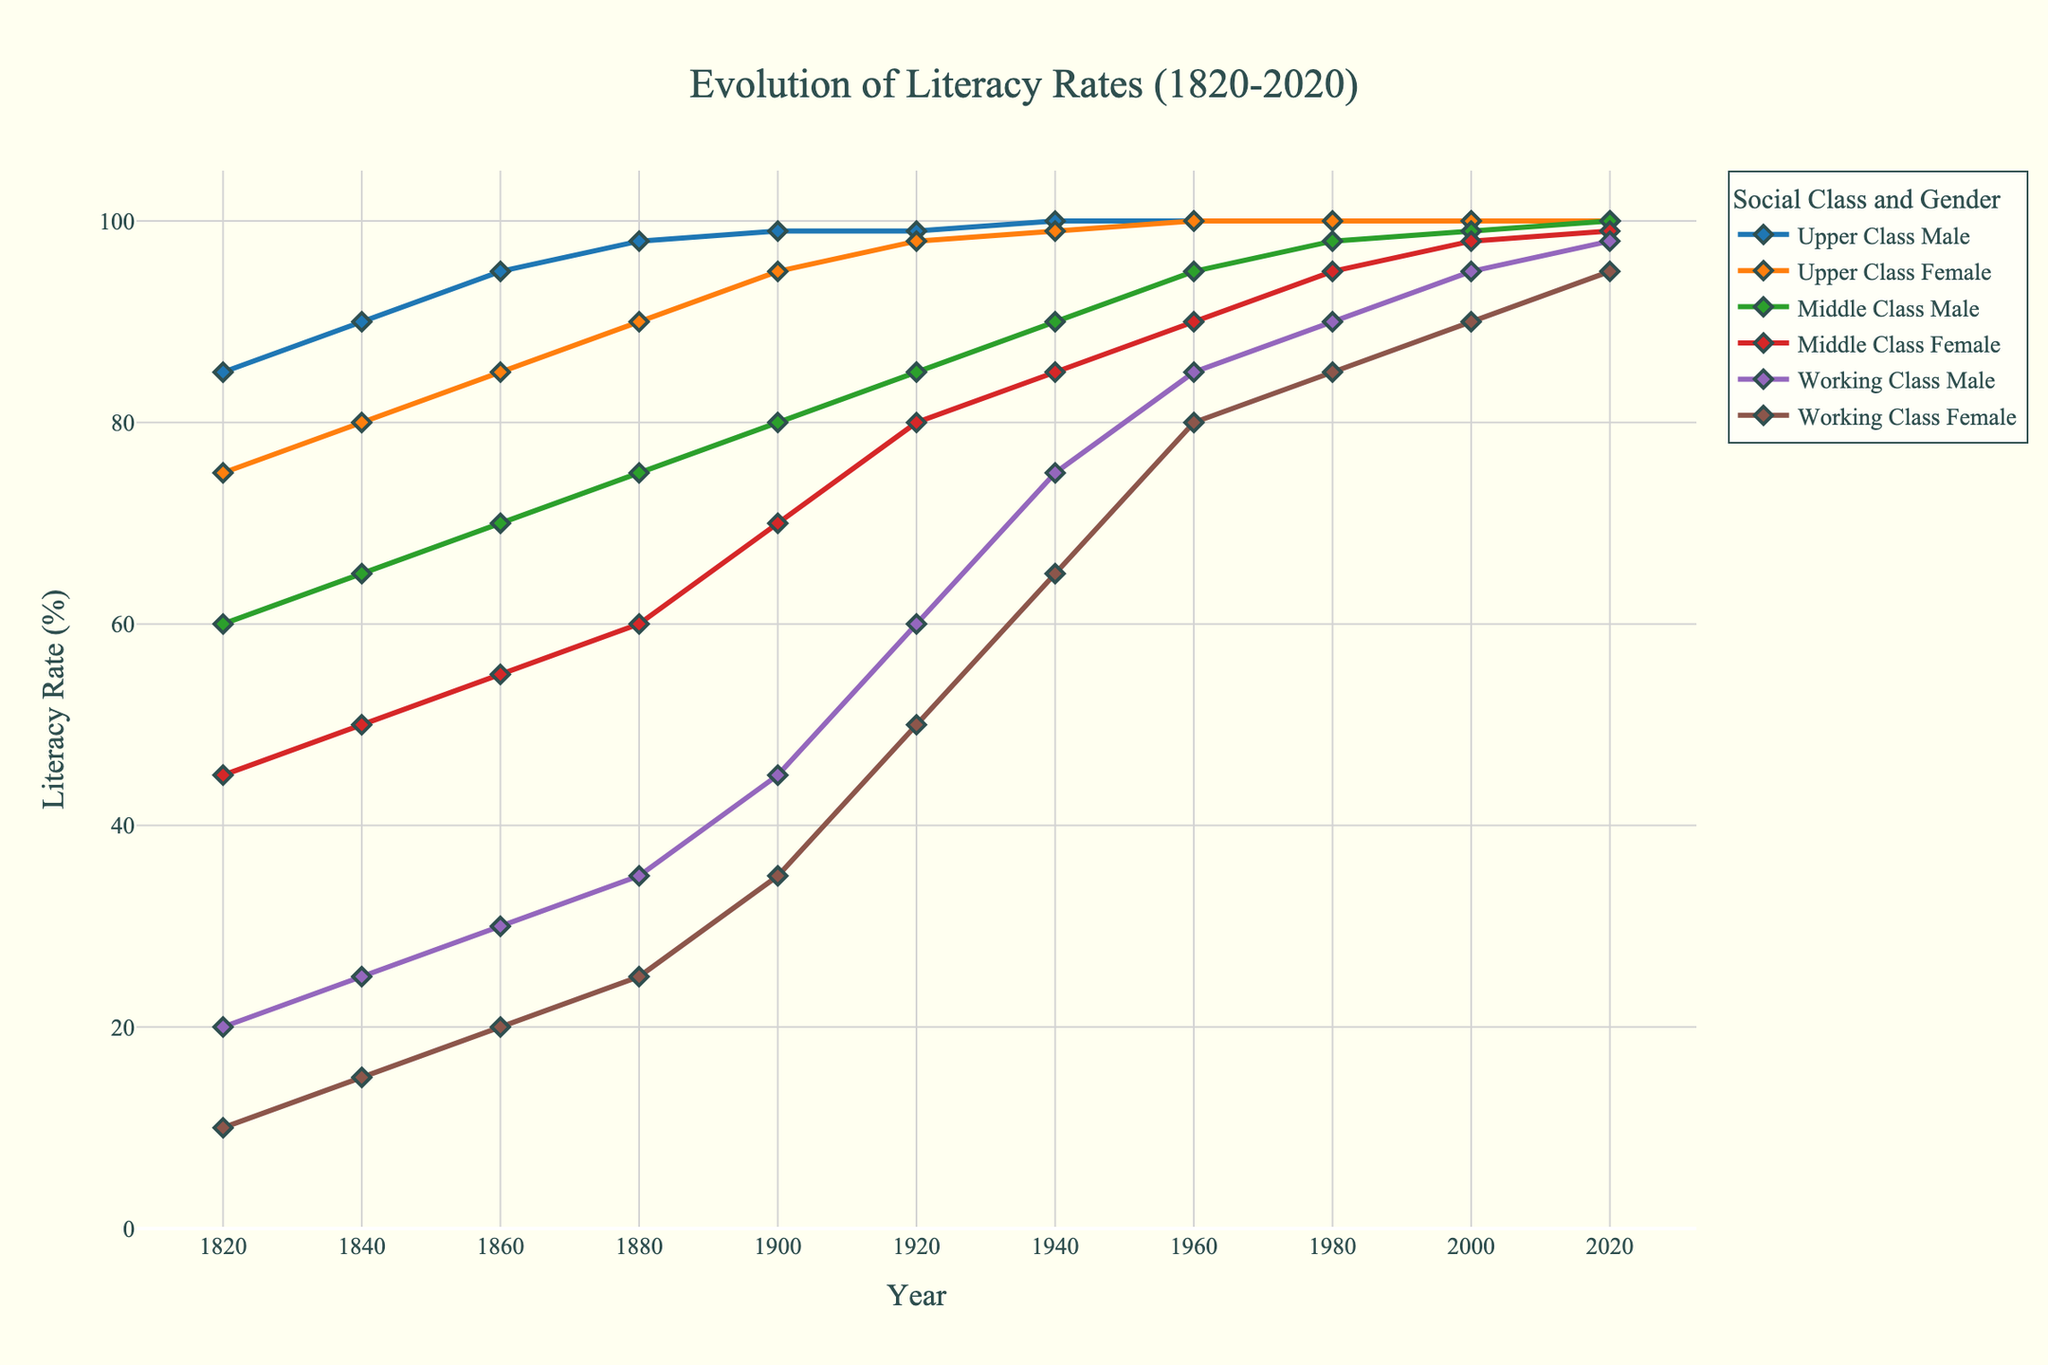**What is the literacy rate of Upper Class Females in the year 1840?** To find the literacy rate of Upper Class Females in 1840, locate the "Upper Class Female" line and find its value at the 1840 mark on the x-axis. The rate is noted at that point.
Answer: 80 **How much did the literacy rate for Working Class Males increase from 1820 to 2020?** Look at the literacy rates for Working Class Males in 1820 and 2020. Subtract the 1820 value (20) from the 2020 value (98). This calculation shows the increase over the years.
Answer: 78 **Which group had the highest literacy rate in 1880, and what was the rate?** Identify the lines at the 1880 mark on the x-axis. The highest point belongs to the "Upper Class Male" group. The literacy rate is read off from the y-axis at that point.
Answer: Upper Class Male, 98 **Between which years did Middle Class Females experience the greatest increase in literacy rate?** Examine the increases in the Middle Class Female line. Compare the differences between each pair of consecutive years and determine that the greatest increase was between 1900 and 1920 (70 to 80).
Answer: 1900 to 1920 **Calculate the average literacy rate for Working Class Females in the 19th century** Note the literacy rates for Working Class Females at each data point in the 19th century (1820: 10, 1840: 15, 1860: 20, 1880: 25, 1900: 35). Sum these rates and divide by the number of years (5). Calculation: (10 + 15 + 20 + 25 + 35) / 5 = 21
Answer: 21 **Compare the literacy rate difference between Middle Class Males and Females in 1920.** Look at the literacy rates for Middle Class Males (85) and Females (80) in 1920. Subtract the female rate from the male rate (85 - 80) to find the difference.
Answer: 5 **How many years after 1820 did Upper Class Females reach a 100% literacy rate?** Find the first year the "Upper Class Female" line reaches 100%. This occurs in 1960. Subtract 1820 from 1960 to find the number of years it took. (1960 - 1820)
Answer: 140 **Identify the group with the lowest literacy rate in 2000 and state the value.** Locate the year 2000 on the x-axis and compare all lines at this point. The "Working Class Female" line is the lowest, and the rate at 2000 is noted.
Answer: Working Class Female, 90 **What was the difference in literacy rates between Upper Class Males and Working Class Females in 1860?** Look at the literacy rates in 1860 for both "Upper Class Male" (95) and "Working Class Female" (20). Subtract the latter from the former (95 - 20).
Answer: 75 **During which decade did Upper Class Males consistently maintain a 100% literacy rate?** To find the decade, identify the first time the "Upper Class Male" line reaches and maintains 100%. This starts in 1940, thus, it's the 1940s decade.
Answer: 1940s 